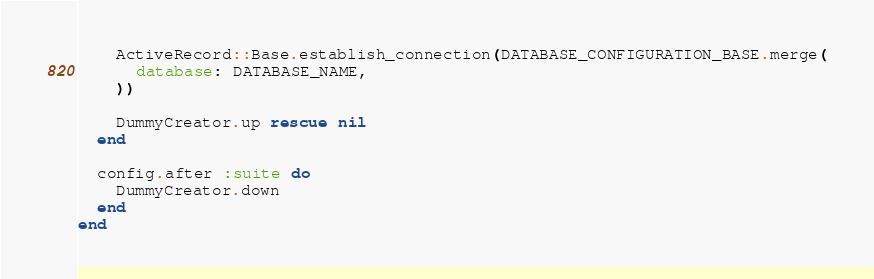<code> <loc_0><loc_0><loc_500><loc_500><_Ruby_>
    ActiveRecord::Base.establish_connection(DATABASE_CONFIGURATION_BASE.merge(
      database: DATABASE_NAME,
    ))

    DummyCreator.up rescue nil
  end

  config.after :suite do
    DummyCreator.down
  end
end
</code> 